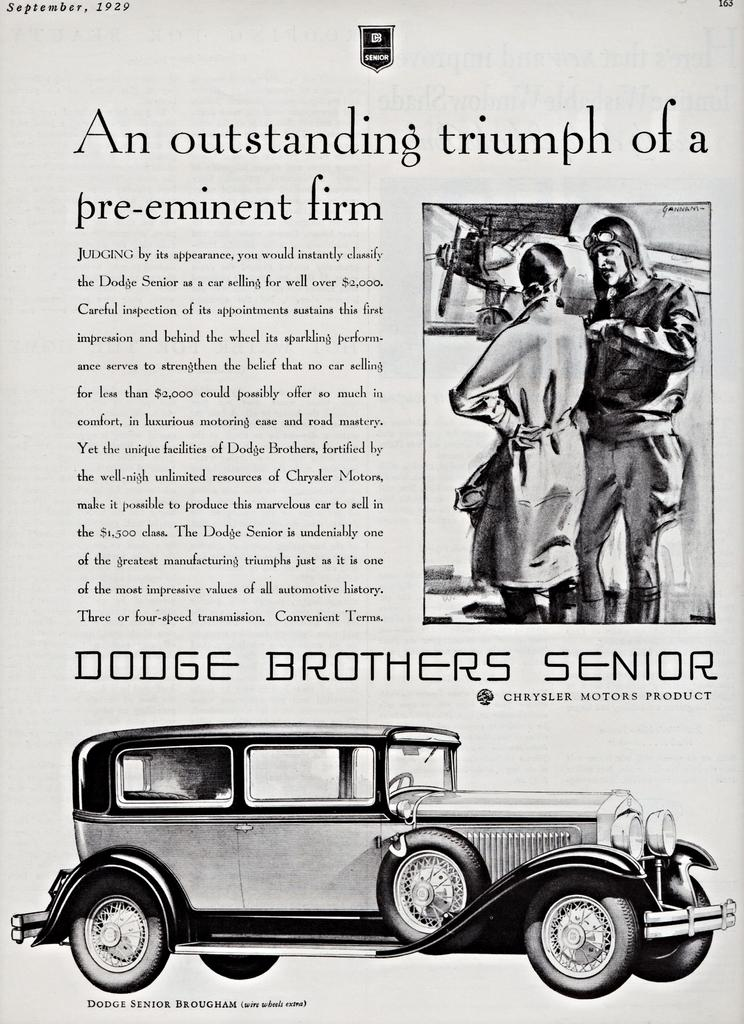What is the primary object in the image? There is a paper in the image. What can be found on the paper? Text is written on the paper, and there is a car image and a person image printed on it. What type of rest can be seen in the image? There is no rest or resting activity depicted in the image; it features a paper with text and images. 